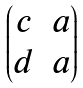Convert formula to latex. <formula><loc_0><loc_0><loc_500><loc_500>\begin{pmatrix} c & a \\ d & a \end{pmatrix}</formula> 